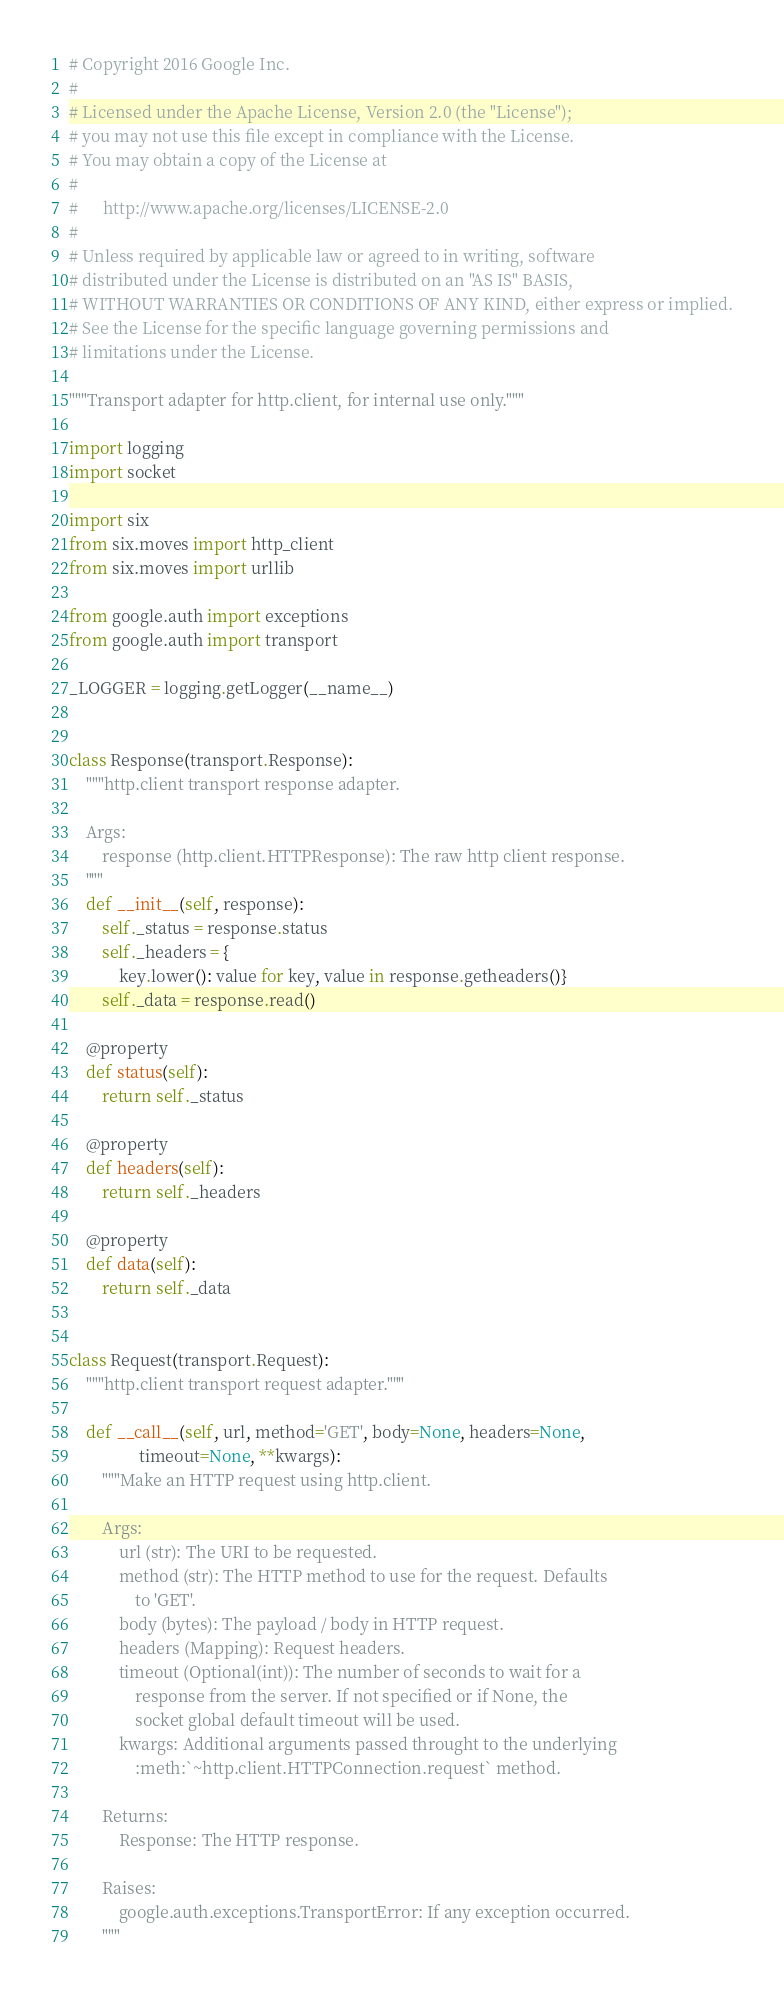<code> <loc_0><loc_0><loc_500><loc_500><_Python_># Copyright 2016 Google Inc.
#
# Licensed under the Apache License, Version 2.0 (the "License");
# you may not use this file except in compliance with the License.
# You may obtain a copy of the License at
#
#      http://www.apache.org/licenses/LICENSE-2.0
#
# Unless required by applicable law or agreed to in writing, software
# distributed under the License is distributed on an "AS IS" BASIS,
# WITHOUT WARRANTIES OR CONDITIONS OF ANY KIND, either express or implied.
# See the License for the specific language governing permissions and
# limitations under the License.

"""Transport adapter for http.client, for internal use only."""

import logging
import socket

import six
from six.moves import http_client
from six.moves import urllib

from google.auth import exceptions
from google.auth import transport

_LOGGER = logging.getLogger(__name__)


class Response(transport.Response):
    """http.client transport response adapter.

    Args:
        response (http.client.HTTPResponse): The raw http client response.
    """
    def __init__(self, response):
        self._status = response.status
        self._headers = {
            key.lower(): value for key, value in response.getheaders()}
        self._data = response.read()

    @property
    def status(self):
        return self._status

    @property
    def headers(self):
        return self._headers

    @property
    def data(self):
        return self._data


class Request(transport.Request):
    """http.client transport request adapter."""

    def __call__(self, url, method='GET', body=None, headers=None,
                 timeout=None, **kwargs):
        """Make an HTTP request using http.client.

        Args:
            url (str): The URI to be requested.
            method (str): The HTTP method to use for the request. Defaults
                to 'GET'.
            body (bytes): The payload / body in HTTP request.
            headers (Mapping): Request headers.
            timeout (Optional(int)): The number of seconds to wait for a
                response from the server. If not specified or if None, the
                socket global default timeout will be used.
            kwargs: Additional arguments passed throught to the underlying
                :meth:`~http.client.HTTPConnection.request` method.

        Returns:
            Response: The HTTP response.

        Raises:
            google.auth.exceptions.TransportError: If any exception occurred.
        """</code> 